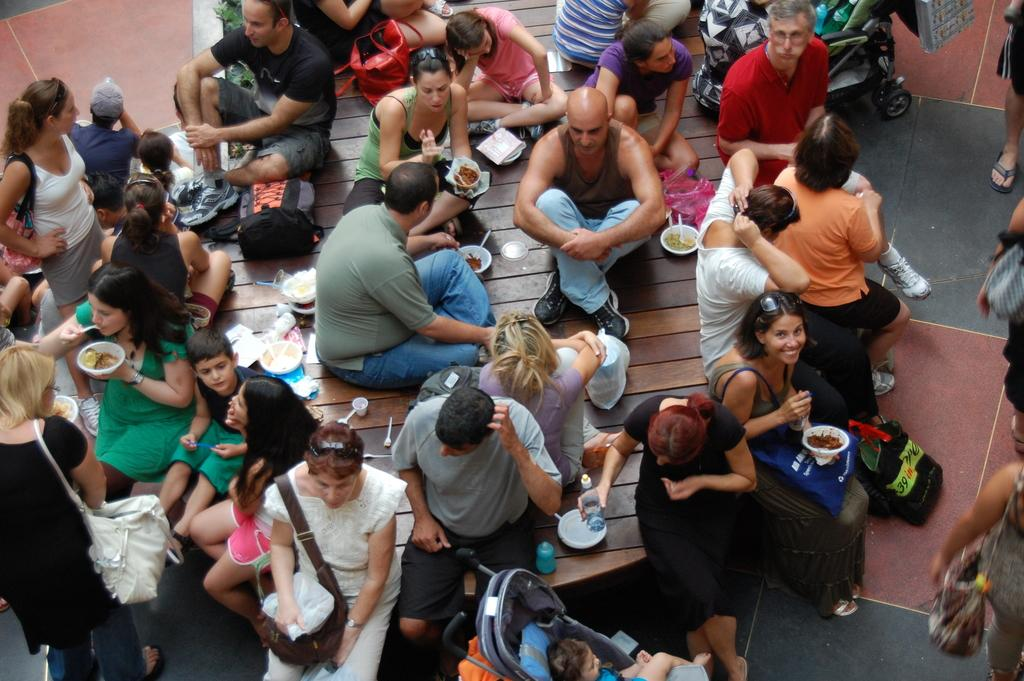What is the main activity of the people in the image? There is a group of people standing and another group sitting at a table in the image. What objects are present on the table? There are bowls and plates visible on the table in the image. What type of clouds can be seen in the image? There are no clouds visible in the image; it is focused on the people and objects on the table. How many plates are stacked on top of each other in the image? The image does not show any plates stacked on top of each other; they are placed flat on the table. 